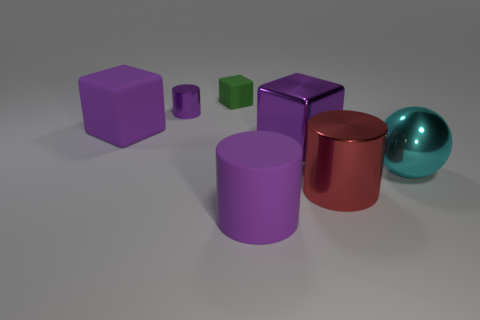Are there an equal number of purple metal objects that are on the right side of the tiny purple cylinder and large shiny cubes that are in front of the purple rubber cube?
Offer a terse response. Yes. There is a rubber object that is left of the tiny purple thing; does it have the same color as the metallic cylinder behind the cyan metallic thing?
Your answer should be very brief. Yes. Is the number of red things in front of the purple metal cylinder greater than the number of purple matte balls?
Offer a terse response. Yes. What is the shape of the tiny thing that is the same material as the red cylinder?
Offer a terse response. Cylinder. Does the purple metal object that is right of the green matte block have the same size as the green thing?
Your answer should be compact. No. What is the shape of the small green object that is to the left of the purple cylinder right of the small purple metallic thing?
Your response must be concise. Cube. There is a purple shiny cube on the right side of the purple cylinder to the left of the tiny green matte block; what size is it?
Give a very brief answer. Large. The big rubber thing in front of the big metal cylinder is what color?
Your response must be concise. Purple. There is a purple cylinder that is the same material as the big ball; what is its size?
Make the answer very short. Small. How many big purple objects have the same shape as the large cyan object?
Offer a very short reply. 0. 